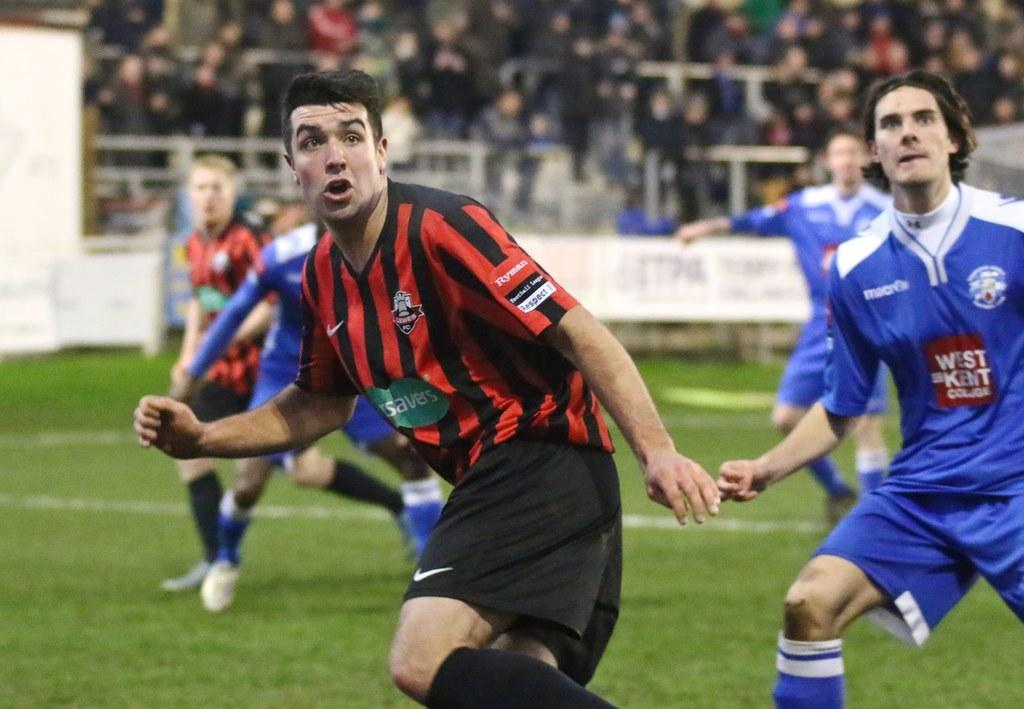Who is present in the image? There are persons in the image. What are the persons wearing? The persons are wearing blue and red dresses. What are the persons doing in the image? The persons are running on a greenery ground. Can you describe the setting in the background of the image? There are audience members in the background of the image. What type of system is being used by the bat to pickle the persons in the image? There is no bat or pickling system present in the image; it features persons running on a greenery ground with audience members in the background. 